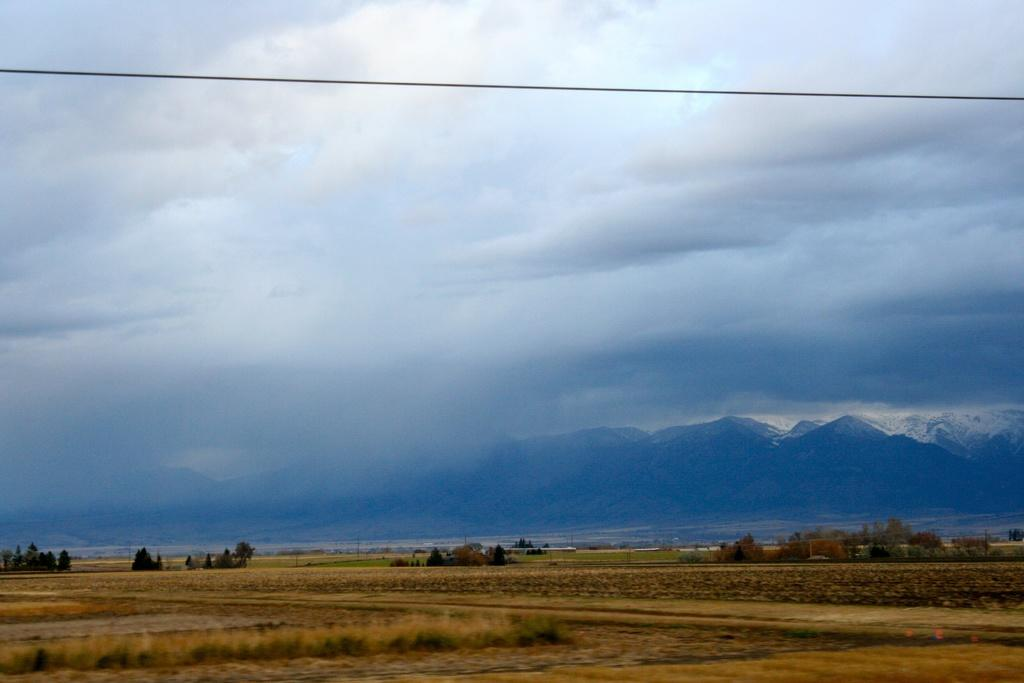What can be seen in the sky in the image? The sky with clouds is visible in the image. What type of object can be seen in the image? There is a cable in the image. What type of natural landscape is present in the image? Mountains are present in the image. What is visible at the bottom of the image? The ground is visible in the image. What type of vegetation is present in the image? Trees are present in the image. What type of object is related to lawn care in the image? There is a lawn straw in the image. Can you see a thumb holding a kitten in the image? No, there is no thumb or kitten present in the image. Is there a note attached to the cable in the image? No, there is no note attached to the cable in the image. 